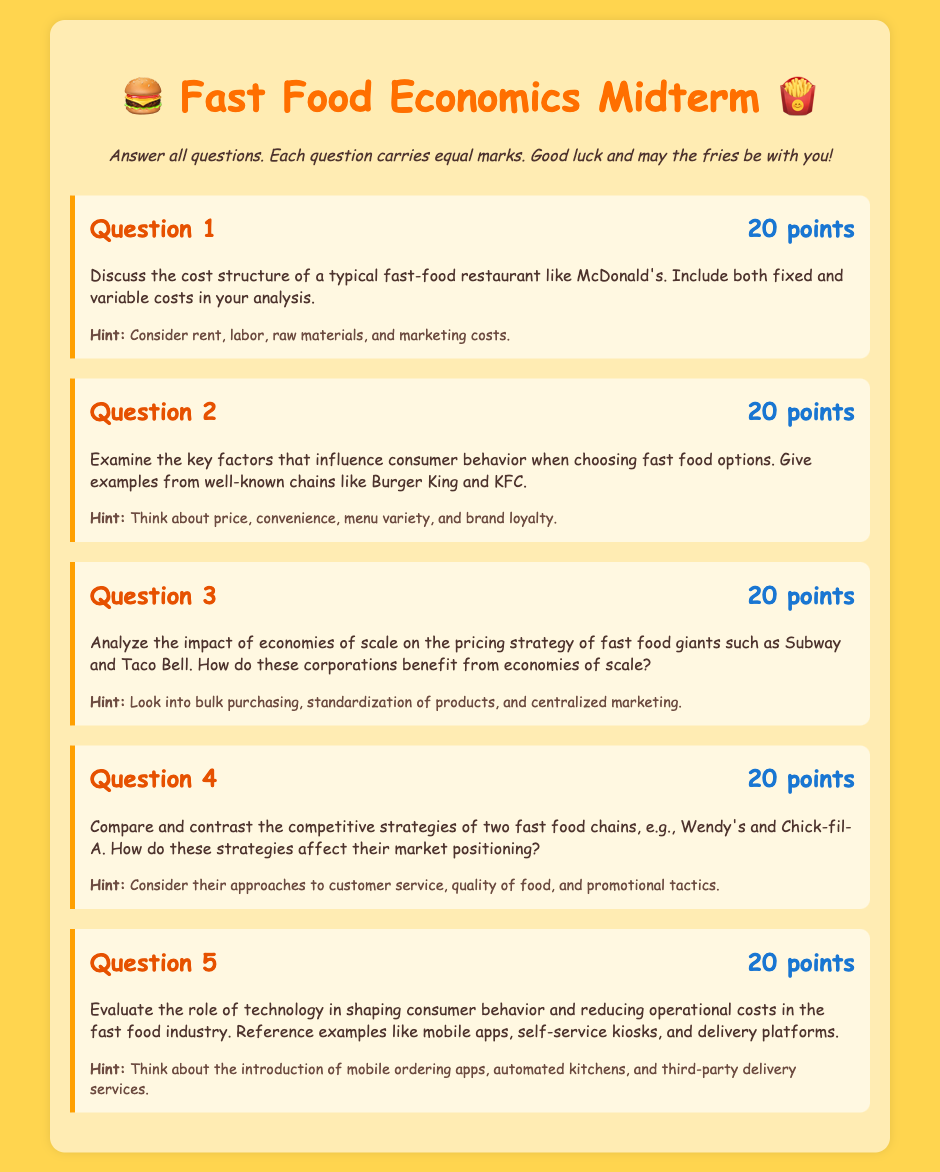What is the maximum score for each question? Each question carries equal marks which is specified in the document as 20 points.
Answer: 20 points What is the focus of Question 2? Question 2 examines the factors influencing consumer behavior when choosing fast food options, with examples from well-known chains.
Answer: Consumer behavior factors What are the two fast food chains compared in Question 4? The document specifies Wendy's and Chick-fil-A as the two fast food chains compared in Question 4.
Answer: Wendy's and Chick-fil-A What technology is mentioned in Question 5 that affects consumer behavior? The document references mobile apps, self-service kiosks, and delivery platforms as technological influences on consumer behavior.
Answer: Mobile apps What is the overall theme of the exam? The midterm exam focuses on the economics of fast food, specifically cost analysis and consumer behavior patterns.
Answer: Economics of fast food 